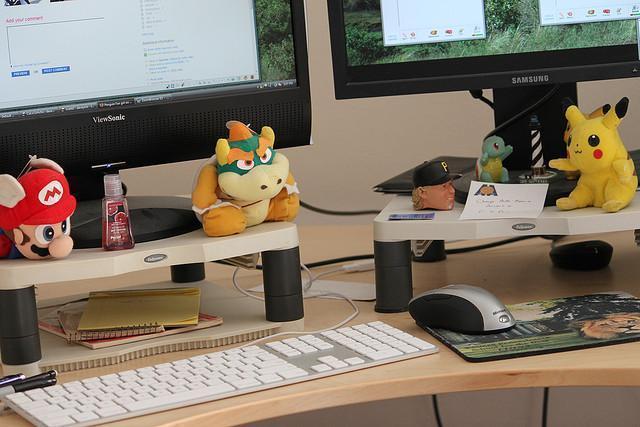What video game does the user of this office space like?
Answer the question by selecting the correct answer among the 4 following choices.
Options: None, super mario, pac man, what's app. Super mario. 